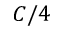Convert formula to latex. <formula><loc_0><loc_0><loc_500><loc_500>C / 4</formula> 